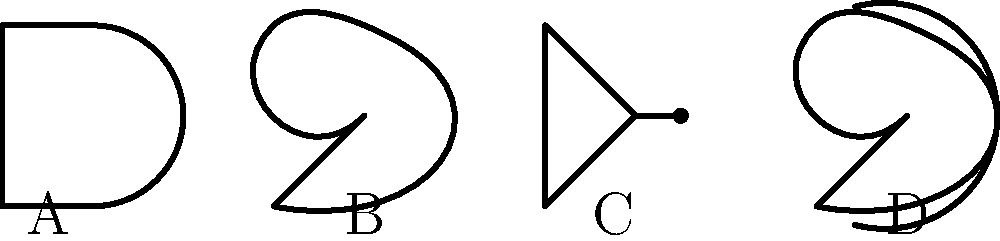As a director at the Australian National Memorial Museum, you're organizing an exhibit on the history of computing. You come across a diagram showing four different logic gate symbols. Can you correctly identify the logic gate represented by symbol C? To answer this question, let's analyze each symbol in the diagram:

1. Symbol A: This symbol has a curved back and straight sides, forming a shape similar to the letter D. This is the standard symbol for an AND gate.

2. Symbol B: This symbol has a curved front and back, forming a shape like a crescent. This represents an OR gate.

3. Symbol C: This symbol is a triangle with a small circle at its point. The triangle alone would represent a buffer, but the addition of the circle at the output indicates inversion. This is the standard symbol for a NOT gate (also called an inverter).

4. Symbol D: This symbol is similar to the OR gate (symbol B), but with an additional curved line at the input. This extra curve represents the "exclusive" property, making this an XOR (exclusive OR) gate.

Therefore, symbol C, which is a triangle with a circle at its point, represents a NOT gate.
Answer: NOT gate 